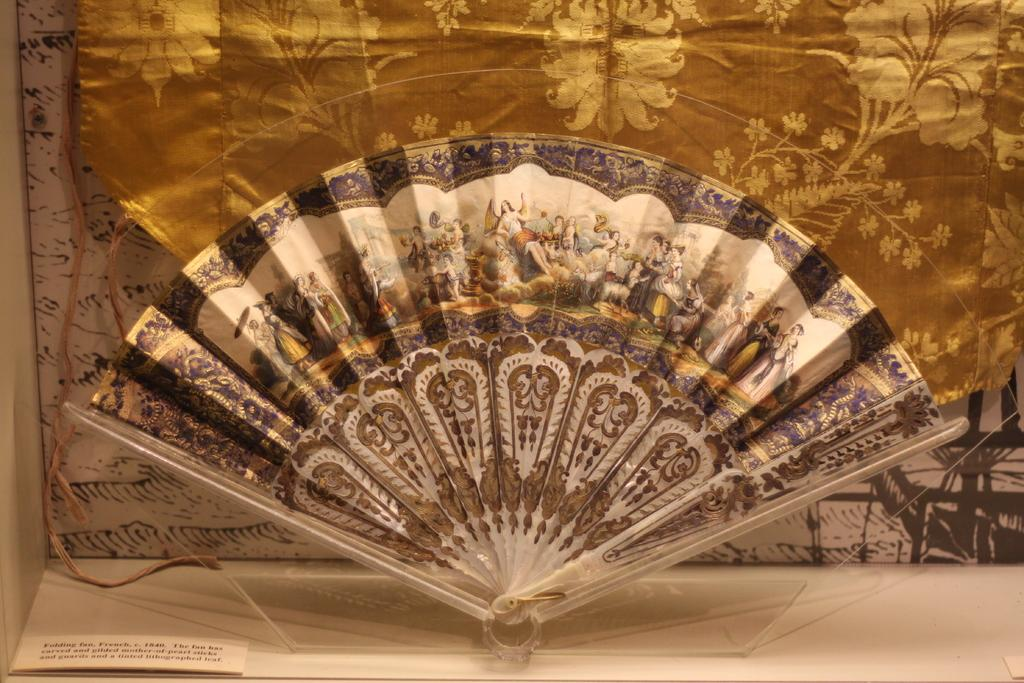What is the shape of the main object in the image? There is an object in the shape of a peacock. What can be found on the peacock-shaped object? The peacock-shaped object has pictures on it. Can you describe the objects behind the peacock-shaped object? Unfortunately, the facts provided do not give any information about the objects behind the peacock-shaped object. What type of music is the band playing in the background of the image? There is no band present in the image, so it is not possible to determine what type of music they might be playing. 